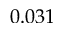<formula> <loc_0><loc_0><loc_500><loc_500>0 . 0 3 1</formula> 